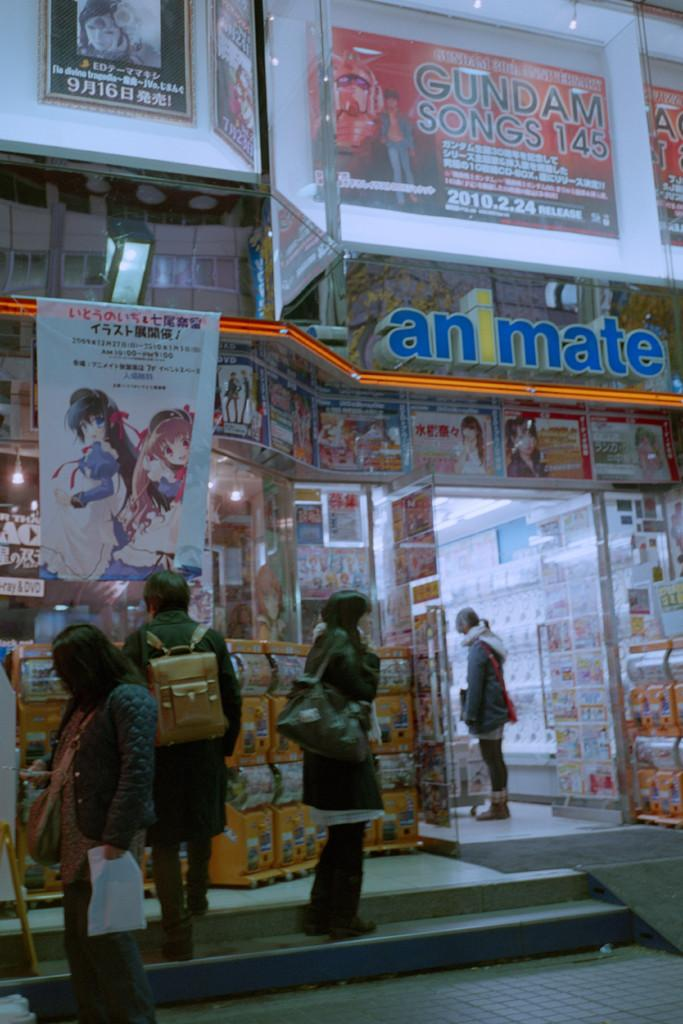What is the main subject in the center of the image? There is a store in the center of the image. Can you describe the people in the image? There are many people standing on a staircase in the image. What is the wind speed in the image? There is no information about wind speed in the image, as it does not mention any weather conditions. 